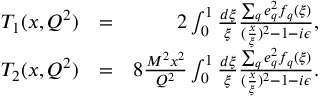Convert formula to latex. <formula><loc_0><loc_0><loc_500><loc_500>\begin{array} { r l r } { T _ { 1 } ( x , Q ^ { 2 } ) } & { = } & { 2 \int _ { 0 } ^ { 1 } \frac { d \xi } { \xi } \frac { \sum _ { q } e _ { q } ^ { 2 } f _ { q } ( \xi ) } { ( \frac { x } { \xi } ) ^ { 2 } - 1 - i \epsilon } , } \\ { T _ { 2 } ( x , Q ^ { 2 } ) } & { = } & { 8 \frac { M ^ { 2 } x ^ { 2 } } { Q ^ { 2 } } \int _ { 0 } ^ { 1 } \frac { d \xi } { \xi } \frac { \sum _ { q } e _ { q } ^ { 2 } f _ { q } ( \xi ) } { ( \frac { x } { \xi } ) ^ { 2 } - 1 - i \epsilon } . } \end{array}</formula> 